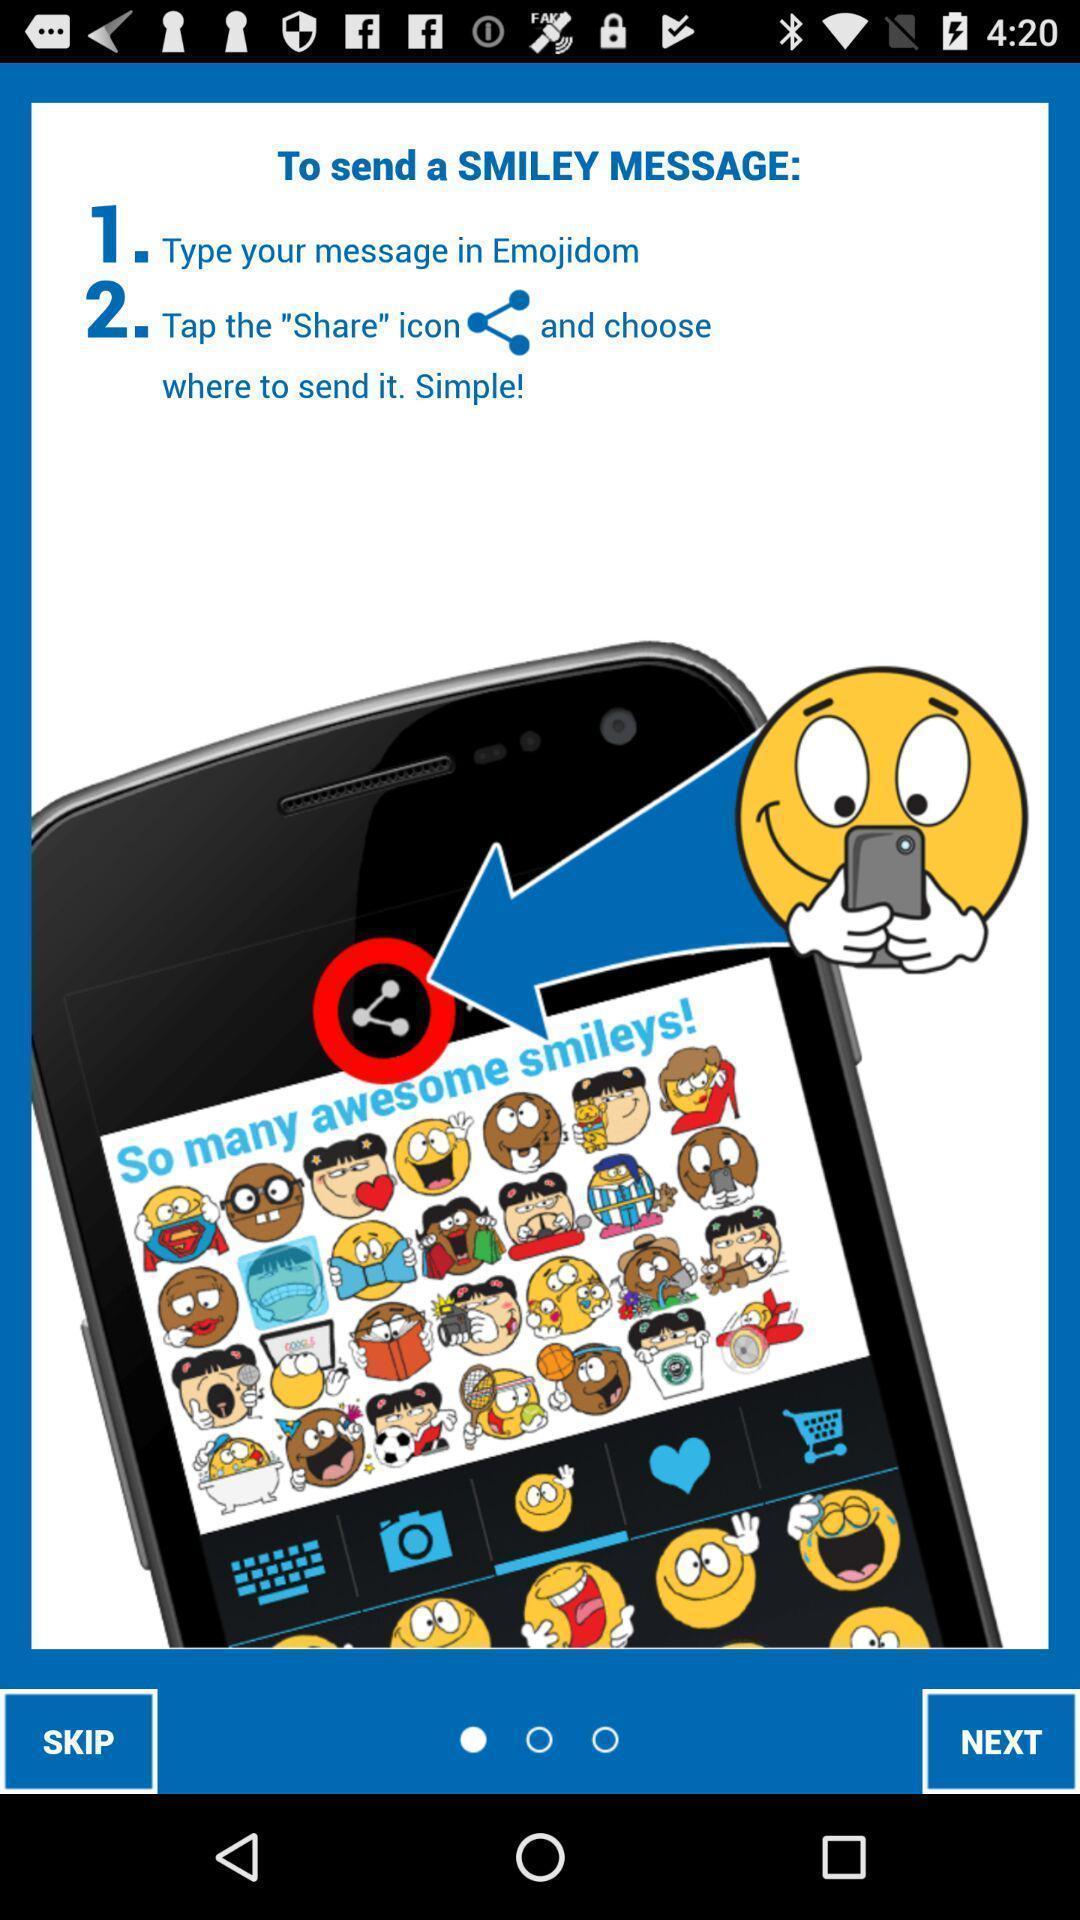Give me a summary of this screen capture. Welcome page for a sticker app. 